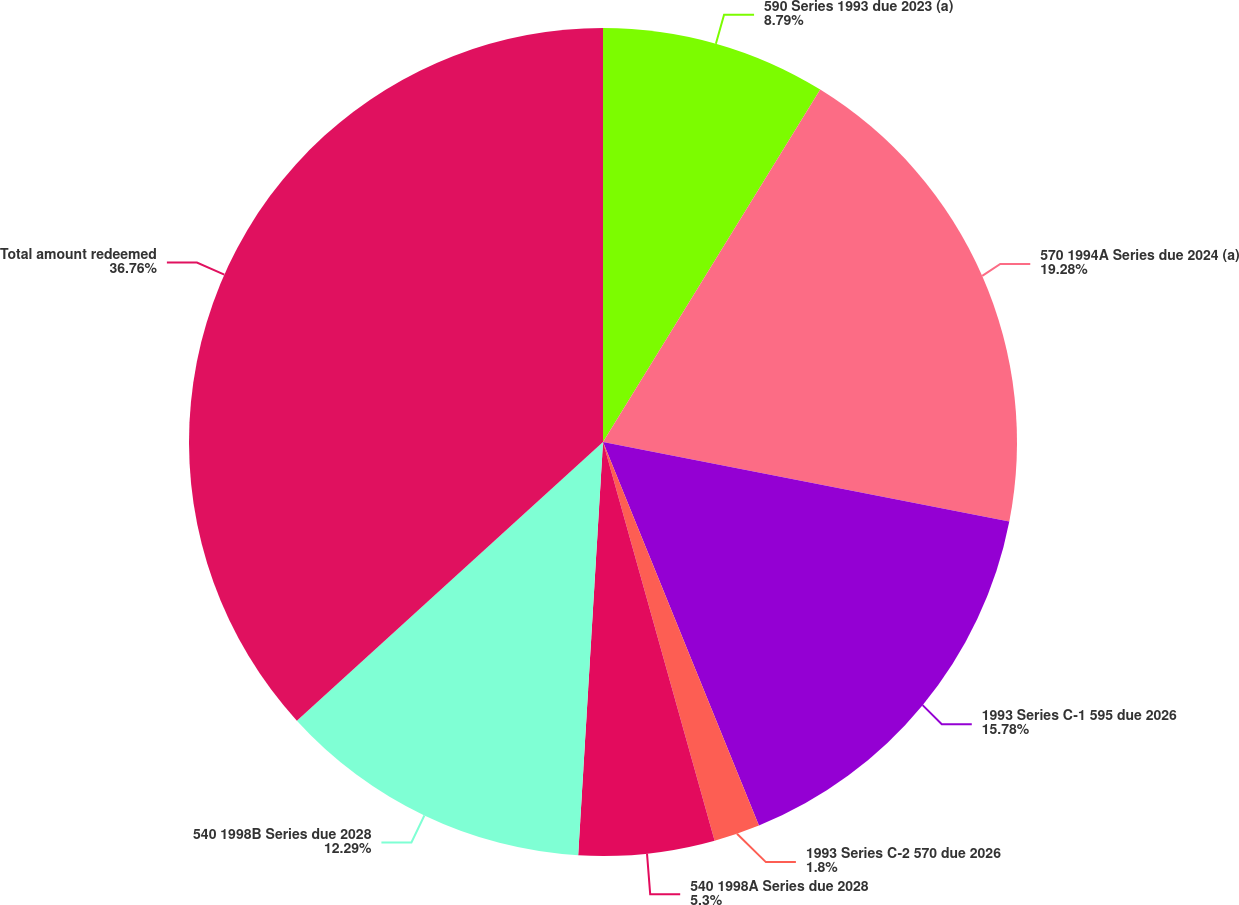Convert chart. <chart><loc_0><loc_0><loc_500><loc_500><pie_chart><fcel>590 Series 1993 due 2023 (a)<fcel>570 1994A Series due 2024 (a)<fcel>1993 Series C-1 595 due 2026<fcel>1993 Series C-2 570 due 2026<fcel>540 1998A Series due 2028<fcel>540 1998B Series due 2028<fcel>Total amount redeemed<nl><fcel>8.79%<fcel>19.28%<fcel>15.78%<fcel>1.8%<fcel>5.3%<fcel>12.29%<fcel>36.75%<nl></chart> 